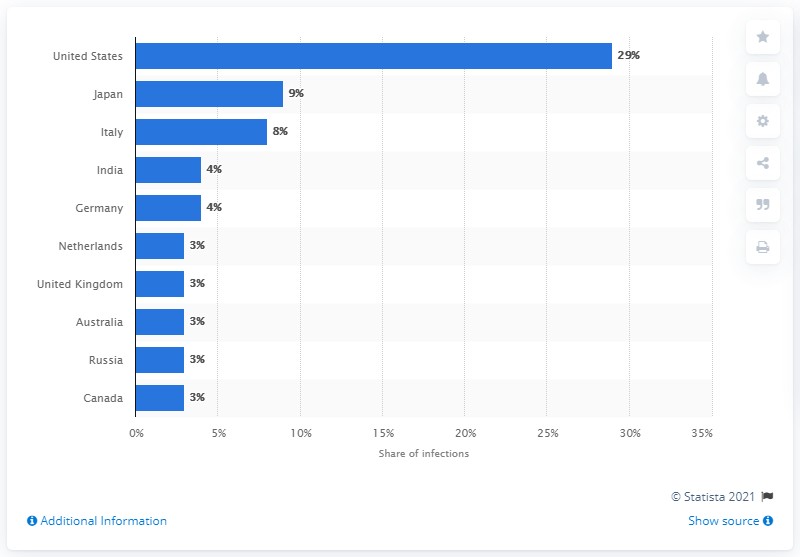Indicate a few pertinent items in this graphic. In 2020, the United States accounted for approximately 29% of global ransomware detections. 